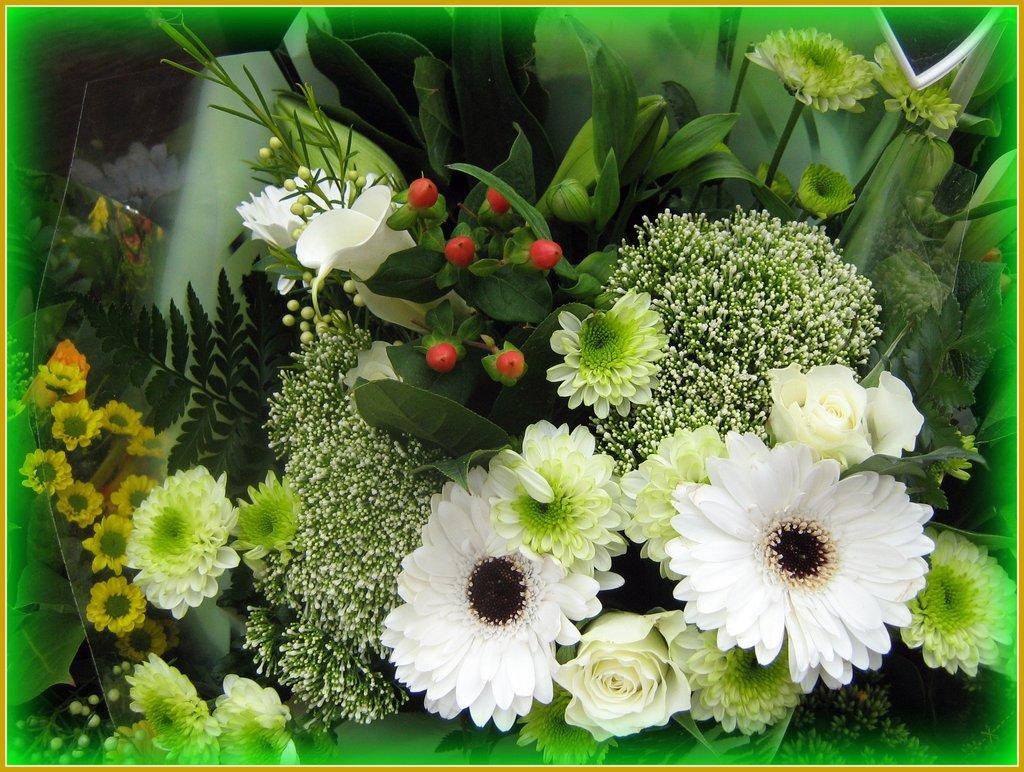What is the main subject of the image? The main subject of the image is a flower bouquet. Can you describe the flower bouquet in the image? The flower bouquet consists of various types of flowers arranged together. What type of hammer is being used by the partner in the image? There is no partner or hammer present in the image; it only features a flower bouquet. 